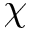<formula> <loc_0><loc_0><loc_500><loc_500>\chi</formula> 